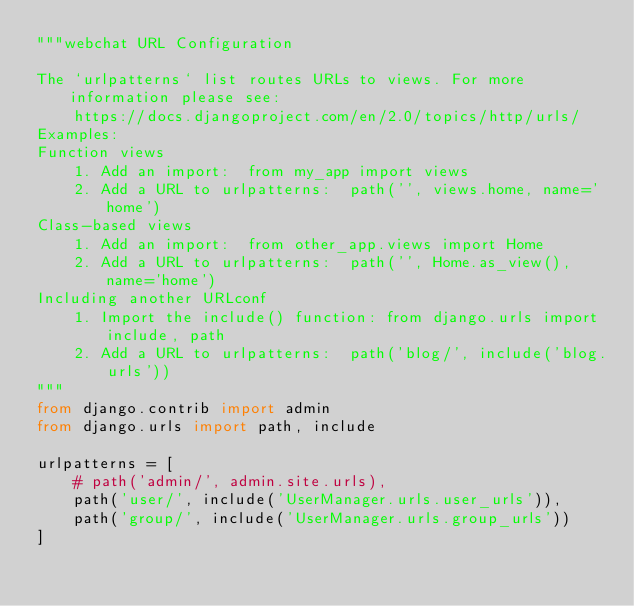<code> <loc_0><loc_0><loc_500><loc_500><_Python_>"""webchat URL Configuration

The `urlpatterns` list routes URLs to views. For more information please see:
    https://docs.djangoproject.com/en/2.0/topics/http/urls/
Examples:
Function views
    1. Add an import:  from my_app import views
    2. Add a URL to urlpatterns:  path('', views.home, name='home')
Class-based views
    1. Add an import:  from other_app.views import Home
    2. Add a URL to urlpatterns:  path('', Home.as_view(), name='home')
Including another URLconf
    1. Import the include() function: from django.urls import include, path
    2. Add a URL to urlpatterns:  path('blog/', include('blog.urls'))
"""
from django.contrib import admin
from django.urls import path, include

urlpatterns = [
    # path('admin/', admin.site.urls),
    path('user/', include('UserManager.urls.user_urls')),
    path('group/', include('UserManager.urls.group_urls'))
]
</code> 